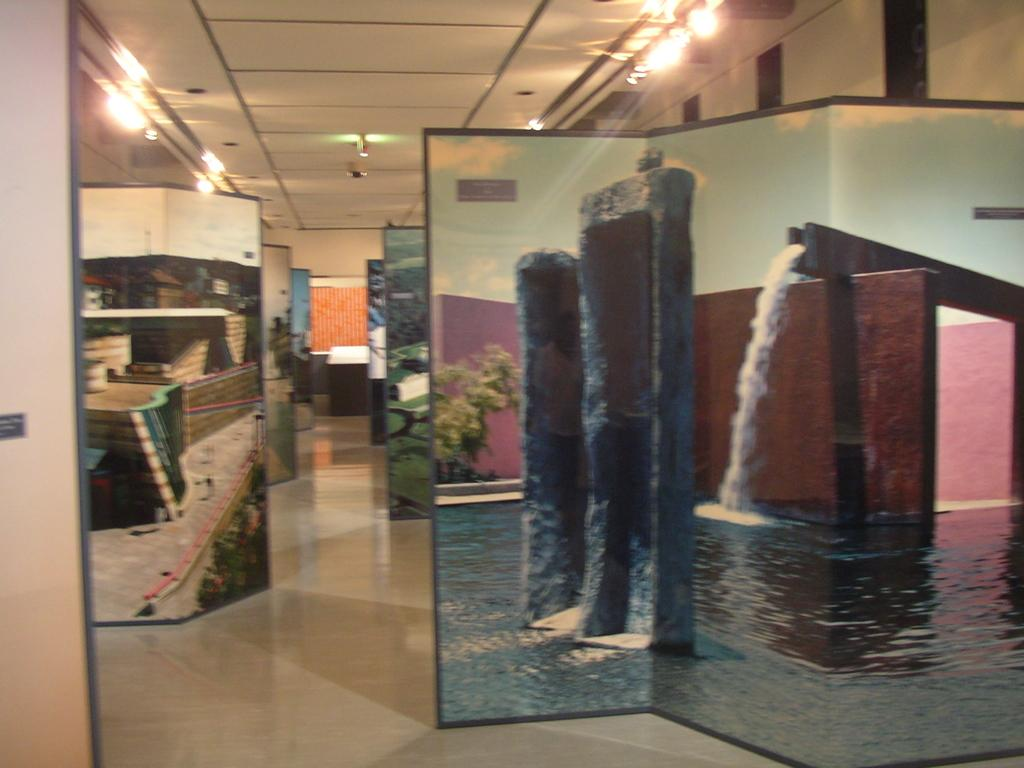What is on the floor in the image? There are boards on the floor in the image. What can be seen in the background of the image? There are lights, tables, and a wall visible in the background of the image. What is the top of the image showing? The top of the image shows a roof. How many legs can be seen on the roof in the image? There are no legs visible on the roof in the image. What type of steam is coming out of the lights in the background? There is no steam coming out of the lights in the background; the lights are stationary. 